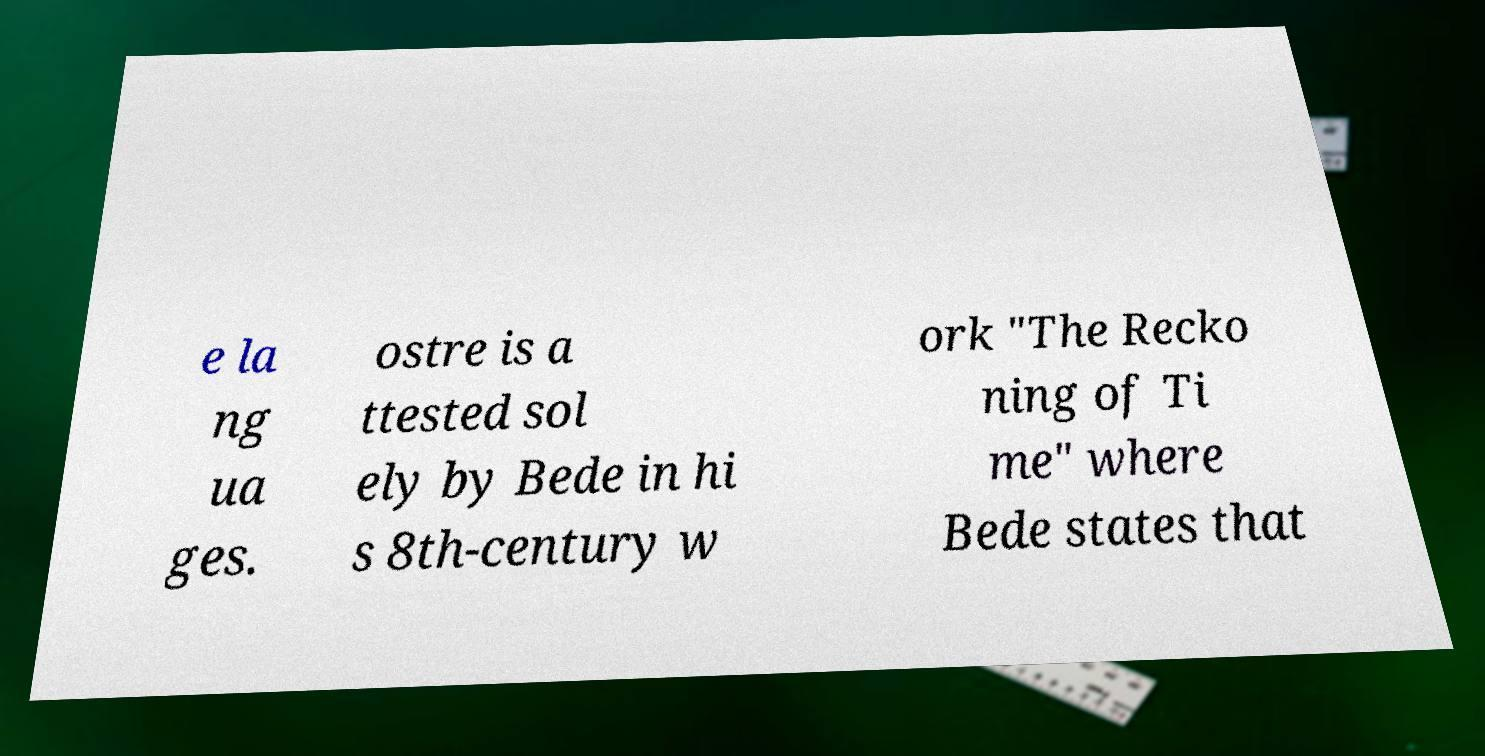Can you read and provide the text displayed in the image?This photo seems to have some interesting text. Can you extract and type it out for me? e la ng ua ges. ostre is a ttested sol ely by Bede in hi s 8th-century w ork "The Recko ning of Ti me" where Bede states that 